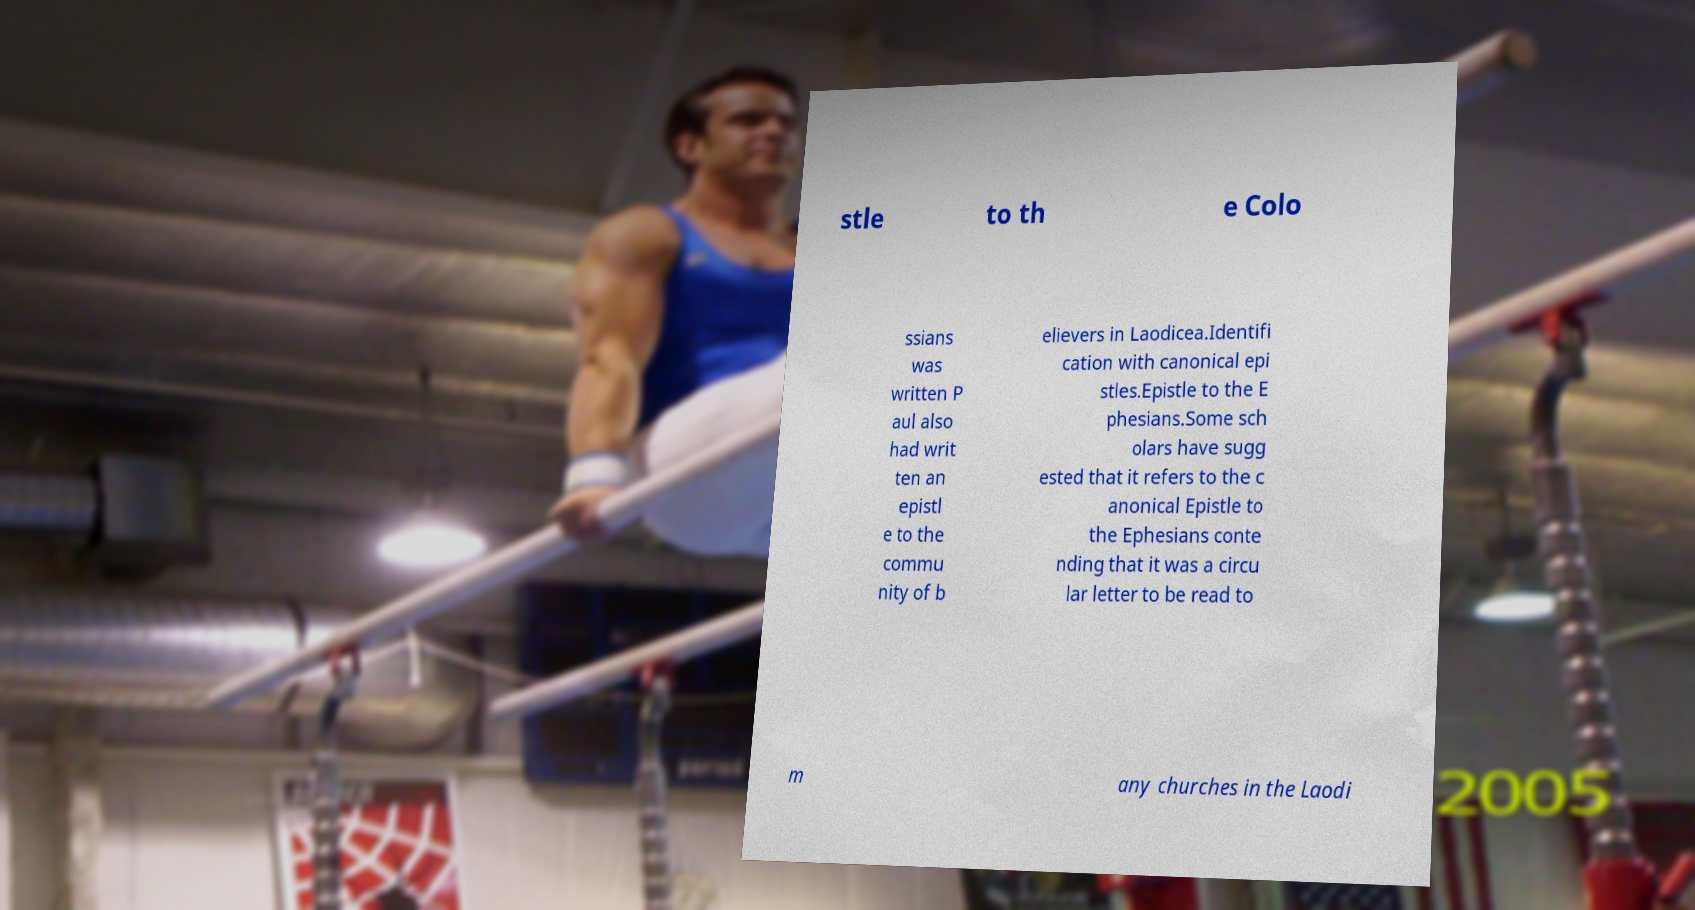I need the written content from this picture converted into text. Can you do that? stle to th e Colo ssians was written P aul also had writ ten an epistl e to the commu nity of b elievers in Laodicea.Identifi cation with canonical epi stles.Epistle to the E phesians.Some sch olars have sugg ested that it refers to the c anonical Epistle to the Ephesians conte nding that it was a circu lar letter to be read to m any churches in the Laodi 